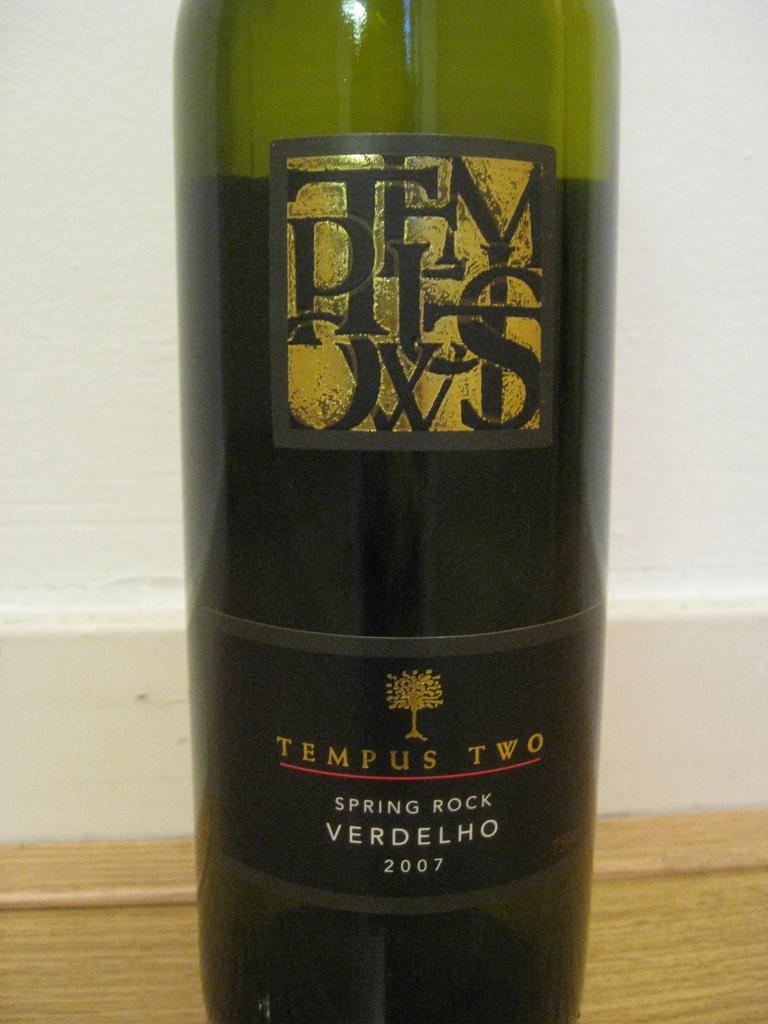Provide a one-sentence caption for the provided image. A bottle of Spring Rock Verdelho wine by Tempus Two. 